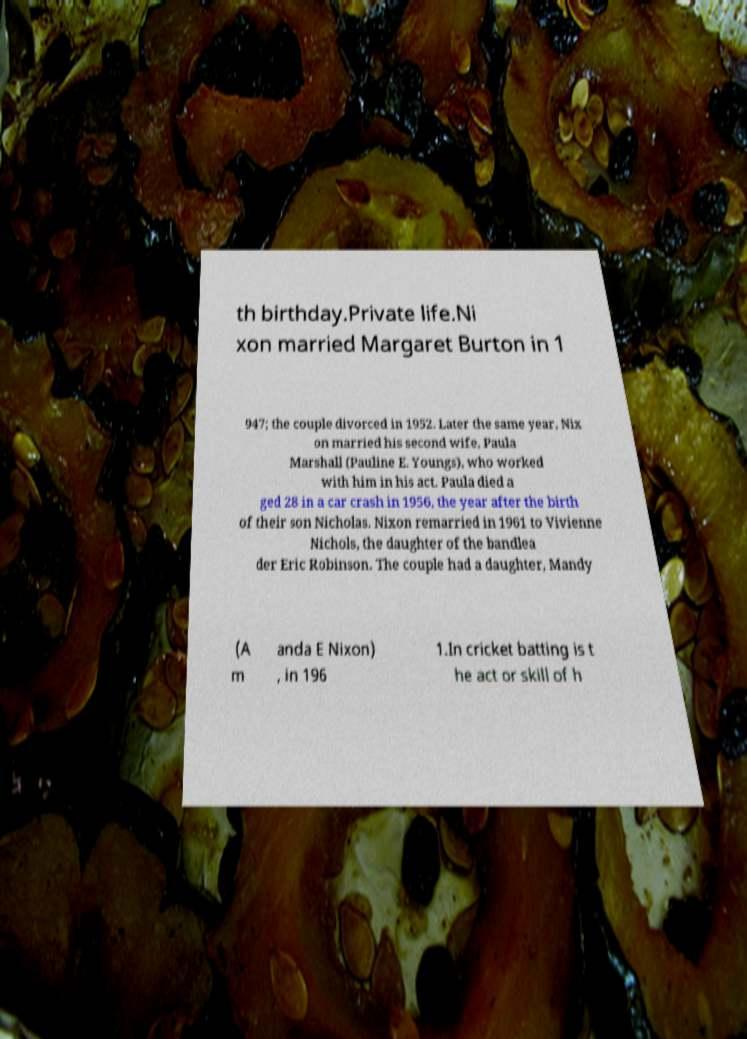I need the written content from this picture converted into text. Can you do that? th birthday.Private life.Ni xon married Margaret Burton in 1 947; the couple divorced in 1952. Later the same year, Nix on married his second wife, Paula Marshall (Pauline E. Youngs), who worked with him in his act. Paula died a ged 28 in a car crash in 1956, the year after the birth of their son Nicholas. Nixon remarried in 1961 to Vivienne Nichols, the daughter of the bandlea der Eric Robinson. The couple had a daughter, Mandy (A m anda E Nixon) , in 196 1.In cricket batting is t he act or skill of h 